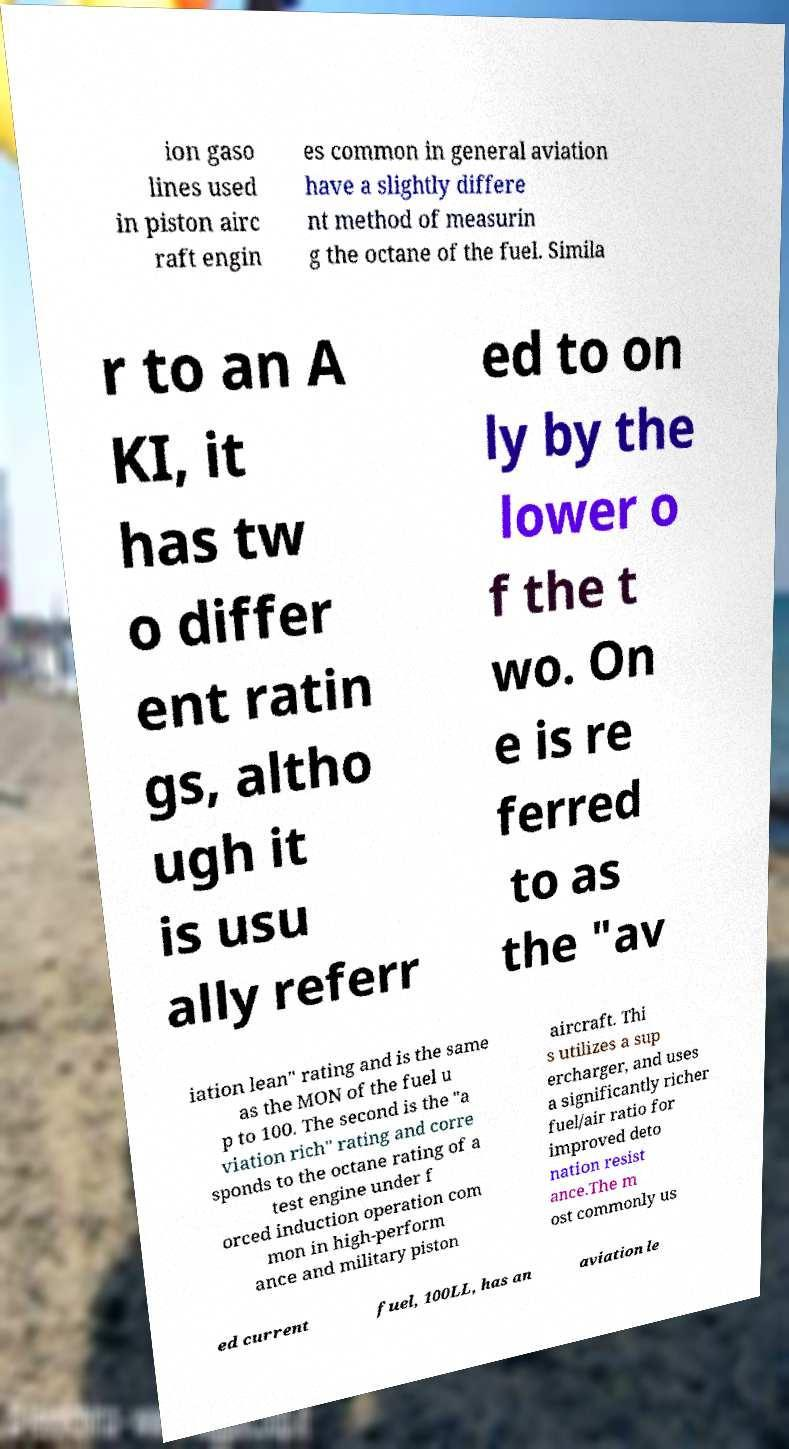There's text embedded in this image that I need extracted. Can you transcribe it verbatim? ion gaso lines used in piston airc raft engin es common in general aviation have a slightly differe nt method of measurin g the octane of the fuel. Simila r to an A KI, it has tw o differ ent ratin gs, altho ugh it is usu ally referr ed to on ly by the lower o f the t wo. On e is re ferred to as the "av iation lean" rating and is the same as the MON of the fuel u p to 100. The second is the "a viation rich" rating and corre sponds to the octane rating of a test engine under f orced induction operation com mon in high-perform ance and military piston aircraft. Thi s utilizes a sup ercharger, and uses a significantly richer fuel/air ratio for improved deto nation resist ance.The m ost commonly us ed current fuel, 100LL, has an aviation le 